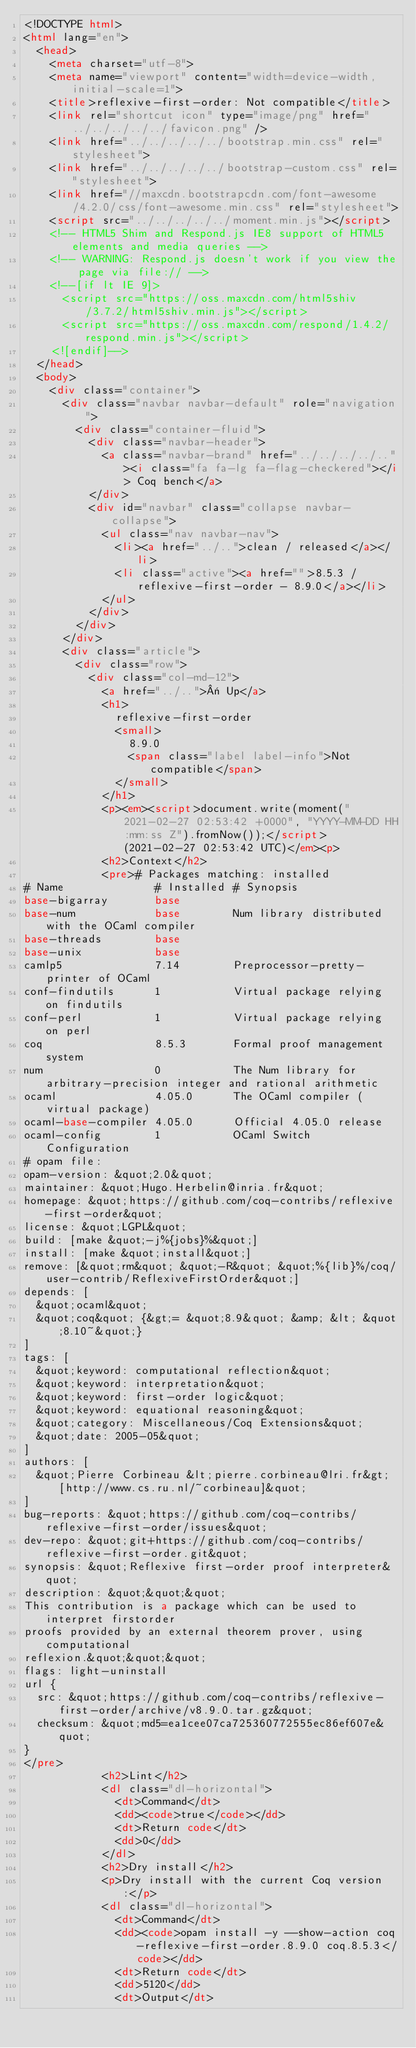Convert code to text. <code><loc_0><loc_0><loc_500><loc_500><_HTML_><!DOCTYPE html>
<html lang="en">
  <head>
    <meta charset="utf-8">
    <meta name="viewport" content="width=device-width, initial-scale=1">
    <title>reflexive-first-order: Not compatible</title>
    <link rel="shortcut icon" type="image/png" href="../../../../../favicon.png" />
    <link href="../../../../../bootstrap.min.css" rel="stylesheet">
    <link href="../../../../../bootstrap-custom.css" rel="stylesheet">
    <link href="//maxcdn.bootstrapcdn.com/font-awesome/4.2.0/css/font-awesome.min.css" rel="stylesheet">
    <script src="../../../../../moment.min.js"></script>
    <!-- HTML5 Shim and Respond.js IE8 support of HTML5 elements and media queries -->
    <!-- WARNING: Respond.js doesn't work if you view the page via file:// -->
    <!--[if lt IE 9]>
      <script src="https://oss.maxcdn.com/html5shiv/3.7.2/html5shiv.min.js"></script>
      <script src="https://oss.maxcdn.com/respond/1.4.2/respond.min.js"></script>
    <![endif]-->
  </head>
  <body>
    <div class="container">
      <div class="navbar navbar-default" role="navigation">
        <div class="container-fluid">
          <div class="navbar-header">
            <a class="navbar-brand" href="../../../../.."><i class="fa fa-lg fa-flag-checkered"></i> Coq bench</a>
          </div>
          <div id="navbar" class="collapse navbar-collapse">
            <ul class="nav navbar-nav">
              <li><a href="../..">clean / released</a></li>
              <li class="active"><a href="">8.5.3 / reflexive-first-order - 8.9.0</a></li>
            </ul>
          </div>
        </div>
      </div>
      <div class="article">
        <div class="row">
          <div class="col-md-12">
            <a href="../..">« Up</a>
            <h1>
              reflexive-first-order
              <small>
                8.9.0
                <span class="label label-info">Not compatible</span>
              </small>
            </h1>
            <p><em><script>document.write(moment("2021-02-27 02:53:42 +0000", "YYYY-MM-DD HH:mm:ss Z").fromNow());</script> (2021-02-27 02:53:42 UTC)</em><p>
            <h2>Context</h2>
            <pre># Packages matching: installed
# Name              # Installed # Synopsis
base-bigarray       base
base-num            base        Num library distributed with the OCaml compiler
base-threads        base
base-unix           base
camlp5              7.14        Preprocessor-pretty-printer of OCaml
conf-findutils      1           Virtual package relying on findutils
conf-perl           1           Virtual package relying on perl
coq                 8.5.3       Formal proof management system
num                 0           The Num library for arbitrary-precision integer and rational arithmetic
ocaml               4.05.0      The OCaml compiler (virtual package)
ocaml-base-compiler 4.05.0      Official 4.05.0 release
ocaml-config        1           OCaml Switch Configuration
# opam file:
opam-version: &quot;2.0&quot;
maintainer: &quot;Hugo.Herbelin@inria.fr&quot;
homepage: &quot;https://github.com/coq-contribs/reflexive-first-order&quot;
license: &quot;LGPL&quot;
build: [make &quot;-j%{jobs}%&quot;]
install: [make &quot;install&quot;]
remove: [&quot;rm&quot; &quot;-R&quot; &quot;%{lib}%/coq/user-contrib/ReflexiveFirstOrder&quot;]
depends: [
  &quot;ocaml&quot;
  &quot;coq&quot; {&gt;= &quot;8.9&quot; &amp; &lt; &quot;8.10~&quot;}
]
tags: [
  &quot;keyword: computational reflection&quot;
  &quot;keyword: interpretation&quot;
  &quot;keyword: first-order logic&quot;
  &quot;keyword: equational reasoning&quot;
  &quot;category: Miscellaneous/Coq Extensions&quot;
  &quot;date: 2005-05&quot;
]
authors: [
  &quot;Pierre Corbineau &lt;pierre.corbineau@lri.fr&gt; [http://www.cs.ru.nl/~corbineau]&quot;
]
bug-reports: &quot;https://github.com/coq-contribs/reflexive-first-order/issues&quot;
dev-repo: &quot;git+https://github.com/coq-contribs/reflexive-first-order.git&quot;
synopsis: &quot;Reflexive first-order proof interpreter&quot;
description: &quot;&quot;&quot;
This contribution is a package which can be used to interpret firstorder
proofs provided by an external theorem prover, using computational
reflexion.&quot;&quot;&quot;
flags: light-uninstall
url {
  src: &quot;https://github.com/coq-contribs/reflexive-first-order/archive/v8.9.0.tar.gz&quot;
  checksum: &quot;md5=ea1cee07ca725360772555ec86ef607e&quot;
}
</pre>
            <h2>Lint</h2>
            <dl class="dl-horizontal">
              <dt>Command</dt>
              <dd><code>true</code></dd>
              <dt>Return code</dt>
              <dd>0</dd>
            </dl>
            <h2>Dry install</h2>
            <p>Dry install with the current Coq version:</p>
            <dl class="dl-horizontal">
              <dt>Command</dt>
              <dd><code>opam install -y --show-action coq-reflexive-first-order.8.9.0 coq.8.5.3</code></dd>
              <dt>Return code</dt>
              <dd>5120</dd>
              <dt>Output</dt></code> 